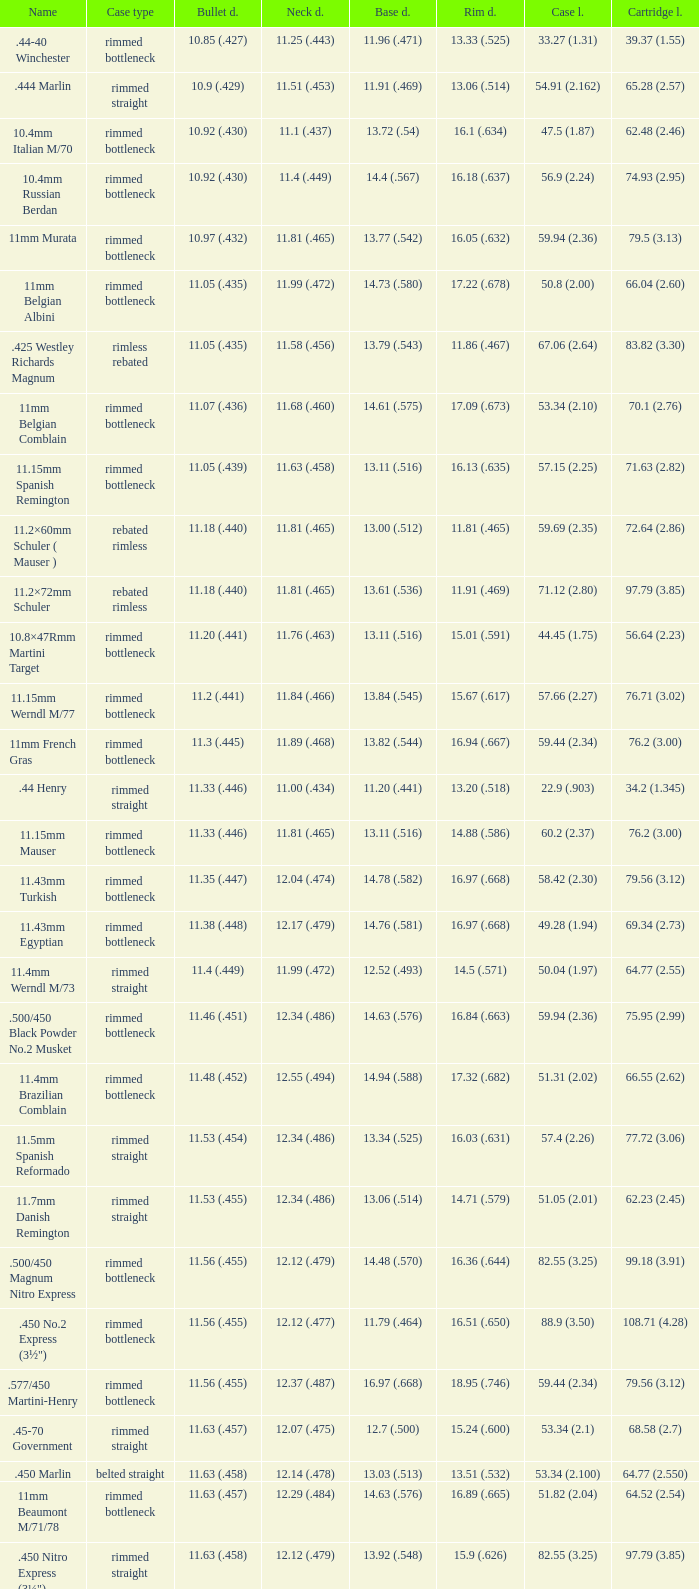Which Case type has a Base diameter of 13.03 (.513), and a Case length of 63.5 (2.5)? Belted straight. 